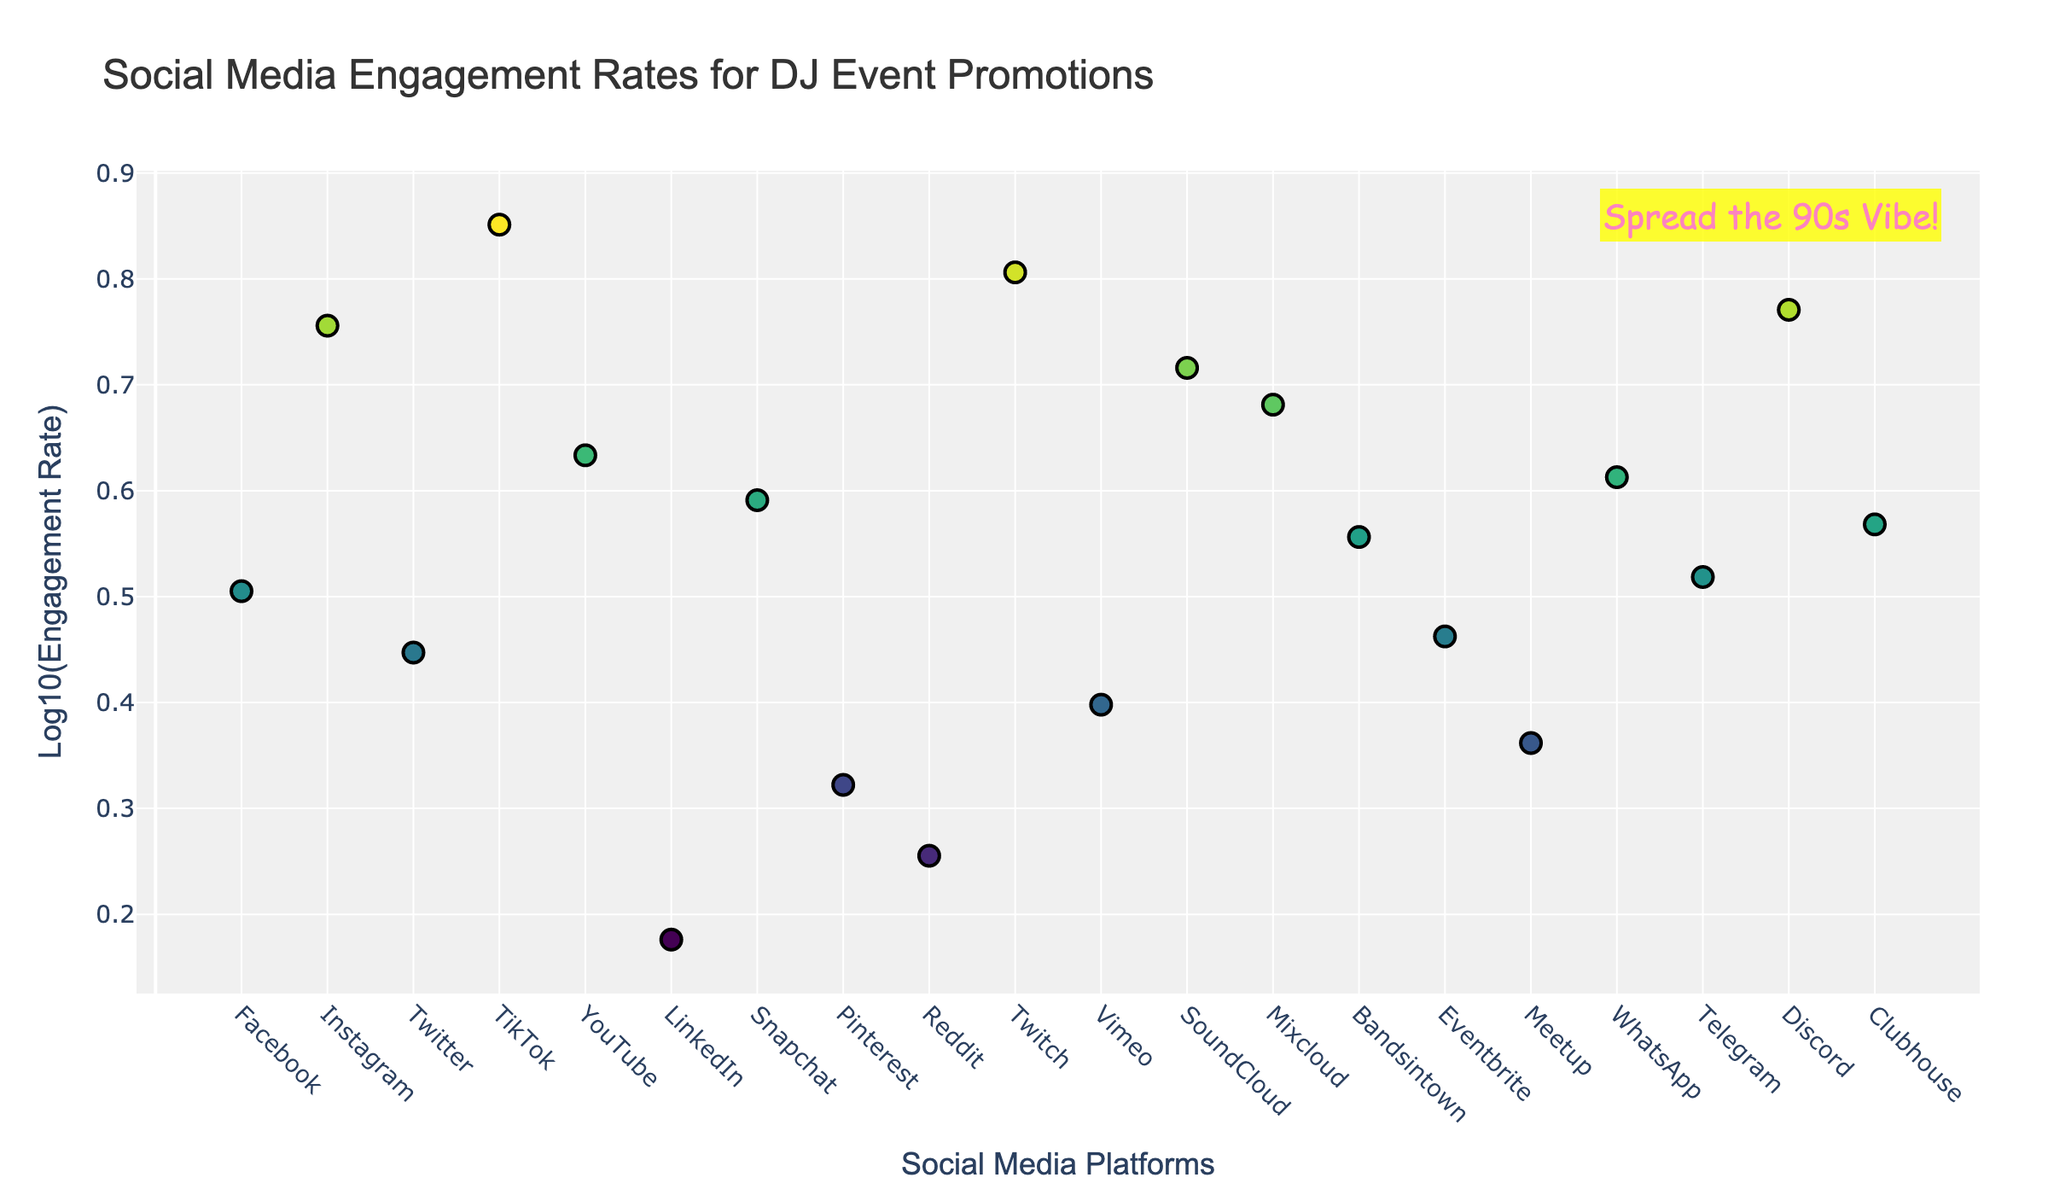What is the highest engagement rate platform? By looking at the scatter plot and identifying the point with the highest y-value corresponding to the engagement rate, TikTok is identified as the platform with the highest engagement rate.
Answer: TikTok What is the lowest engagement rate platform? By identifying the point with the lowest y-value on the y-axis of the plot, LinkedIn is identified as the platform with the lowest engagement rate.
Answer: LinkedIn Which platforms have an engagement rate above 5? By identifying points above the log10(Engagement Rate) value that corresponds to an engagement rate of 5, the platforms TikTok, Instagram, Twitch, Discord, and SoundCloud meed this criterion.
Answer: TikTok, Instagram, Twitch, Discord, SoundCloud Compare the engagement rates of Facebook and WhatsApp. Which one is higher? By locating the points corresponding to Facebook and WhatsApp on the x-axis and comparing the y-values, WhatsApp has a higher engagement rate than Facebook.
Answer: WhatsApp What is the approximate engagement rate of YouTube? By locating YouTube's point on the x-axis and identifying its y-value, YouTube's engagement rate is approximately identified as 4.3.
Answer: 4.3 What is the average engagement rate of platforms whose engagement rate is above 5? Platforms with rates above 5 are TikTok (7.1), Instagram (5.7), Twitch (6.4), Discord (5.9), and SoundCloud (5.2). Calculating the average: (7.1 + 5.7 + 6.4 + 5.9 + 5.2) / 5 = 30.3 / 5.
Answer: 6.06 Which platform is the fourth highest in engagement rate? Sorting and listing the platforms by engagement rate reveals that Discord, with an engagement rate of 5.9, is the fourth highest.
Answer: Discord What is the difference in engagement rates between TikTok and Facebook? Calculating the difference: TikTok (7.1) - Facebook (3.2) = 3.9.
Answer: 3.9 